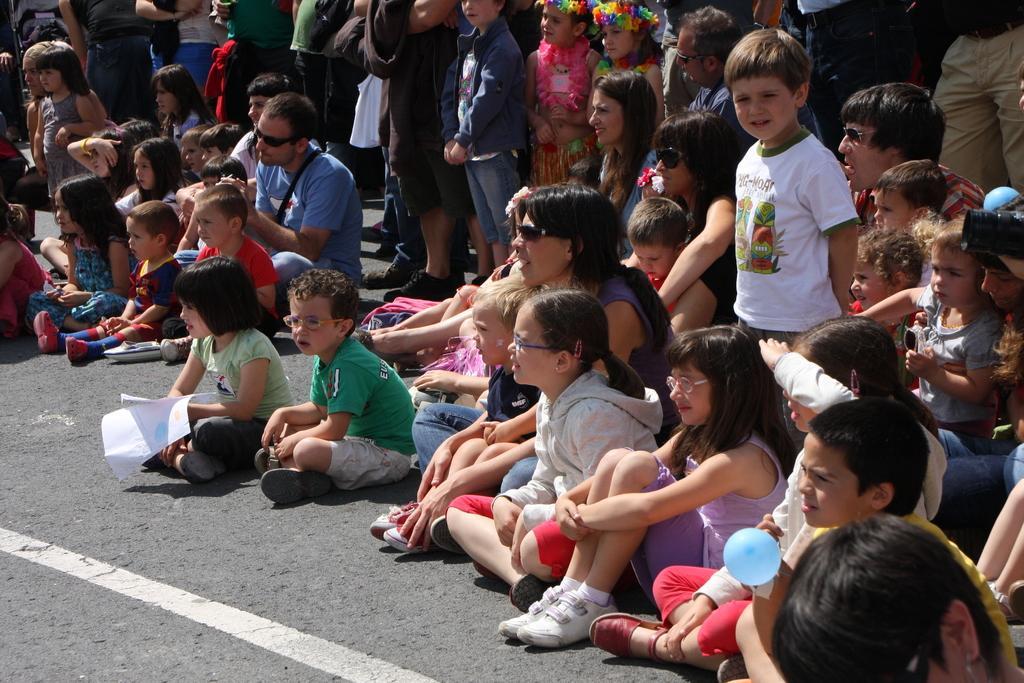Please provide a concise description of this image. In this picture, we see children and people are sitting on the road. The girl in green T-shirt is holding papers in her hands. The boy in yellow T-shirt is holding a balloon. The boy in white T-shirt is standing and he is smiling. In the background, we see children are standing. This picture is clicked outside the city and it is a sunny day. 